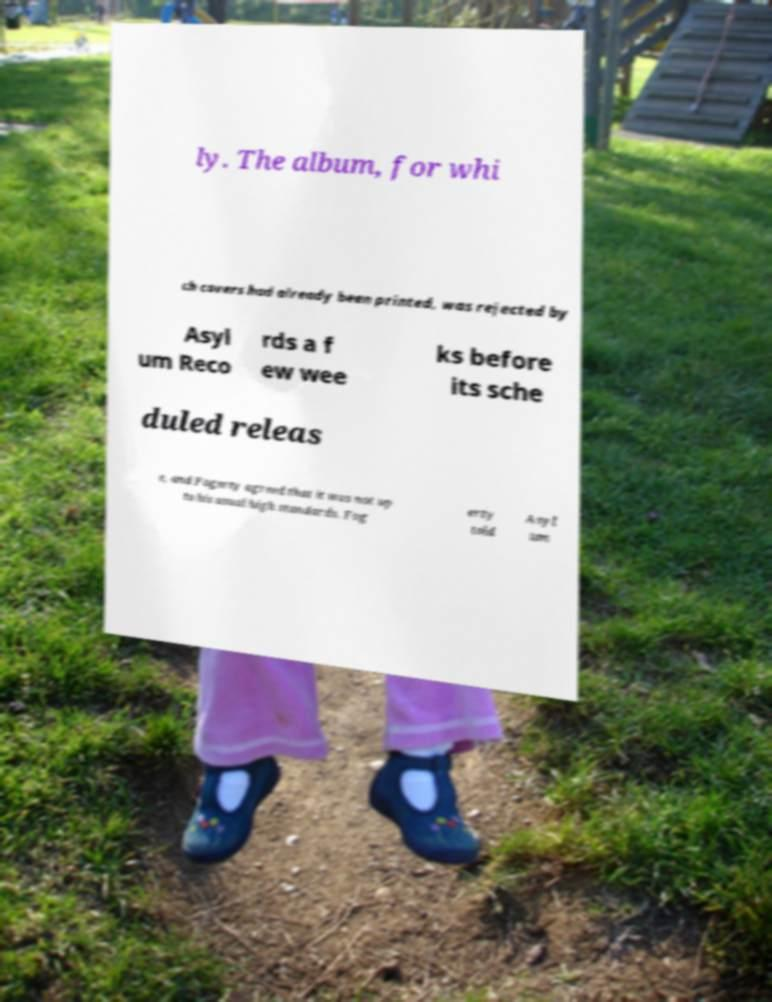Can you read and provide the text displayed in the image?This photo seems to have some interesting text. Can you extract and type it out for me? ly. The album, for whi ch covers had already been printed, was rejected by Asyl um Reco rds a f ew wee ks before its sche duled releas e, and Fogerty agreed that it was not up to his usual high standards. Fog erty told Asyl um 